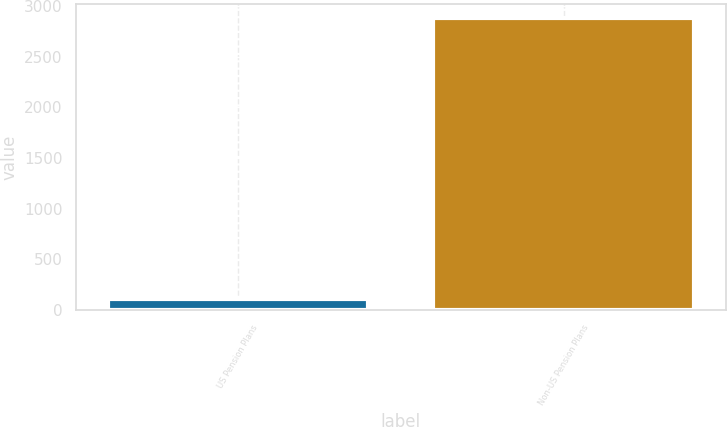<chart> <loc_0><loc_0><loc_500><loc_500><bar_chart><fcel>US Pension Plans<fcel>Non-US Pension Plans<nl><fcel>109<fcel>2876<nl></chart> 